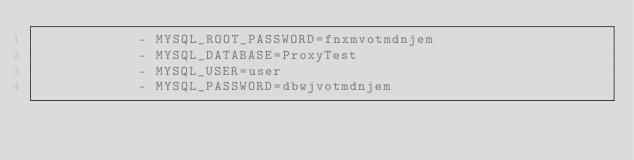<code> <loc_0><loc_0><loc_500><loc_500><_YAML_>            - MYSQL_ROOT_PASSWORD=fnxmvotmdnjem
            - MYSQL_DATABASE=ProxyTest
            - MYSQL_USER=user
            - MYSQL_PASSWORD=dbwjvotmdnjem</code> 